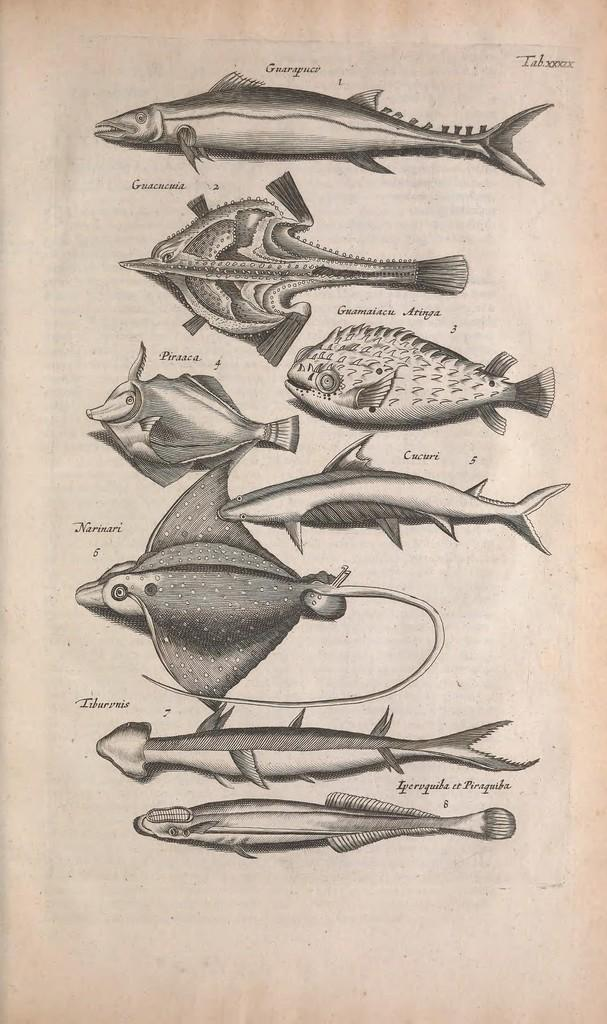What is present in the image that contains drawings? There is a paper in the image that contains sketches of different types of fishes. What can be found on the paper besides the sketches? There is writing on the paper at a few places. Where is the garden located in the image? There is no garden present in the image. What type of back is visible in the image? There is no reference to a back in the image. 